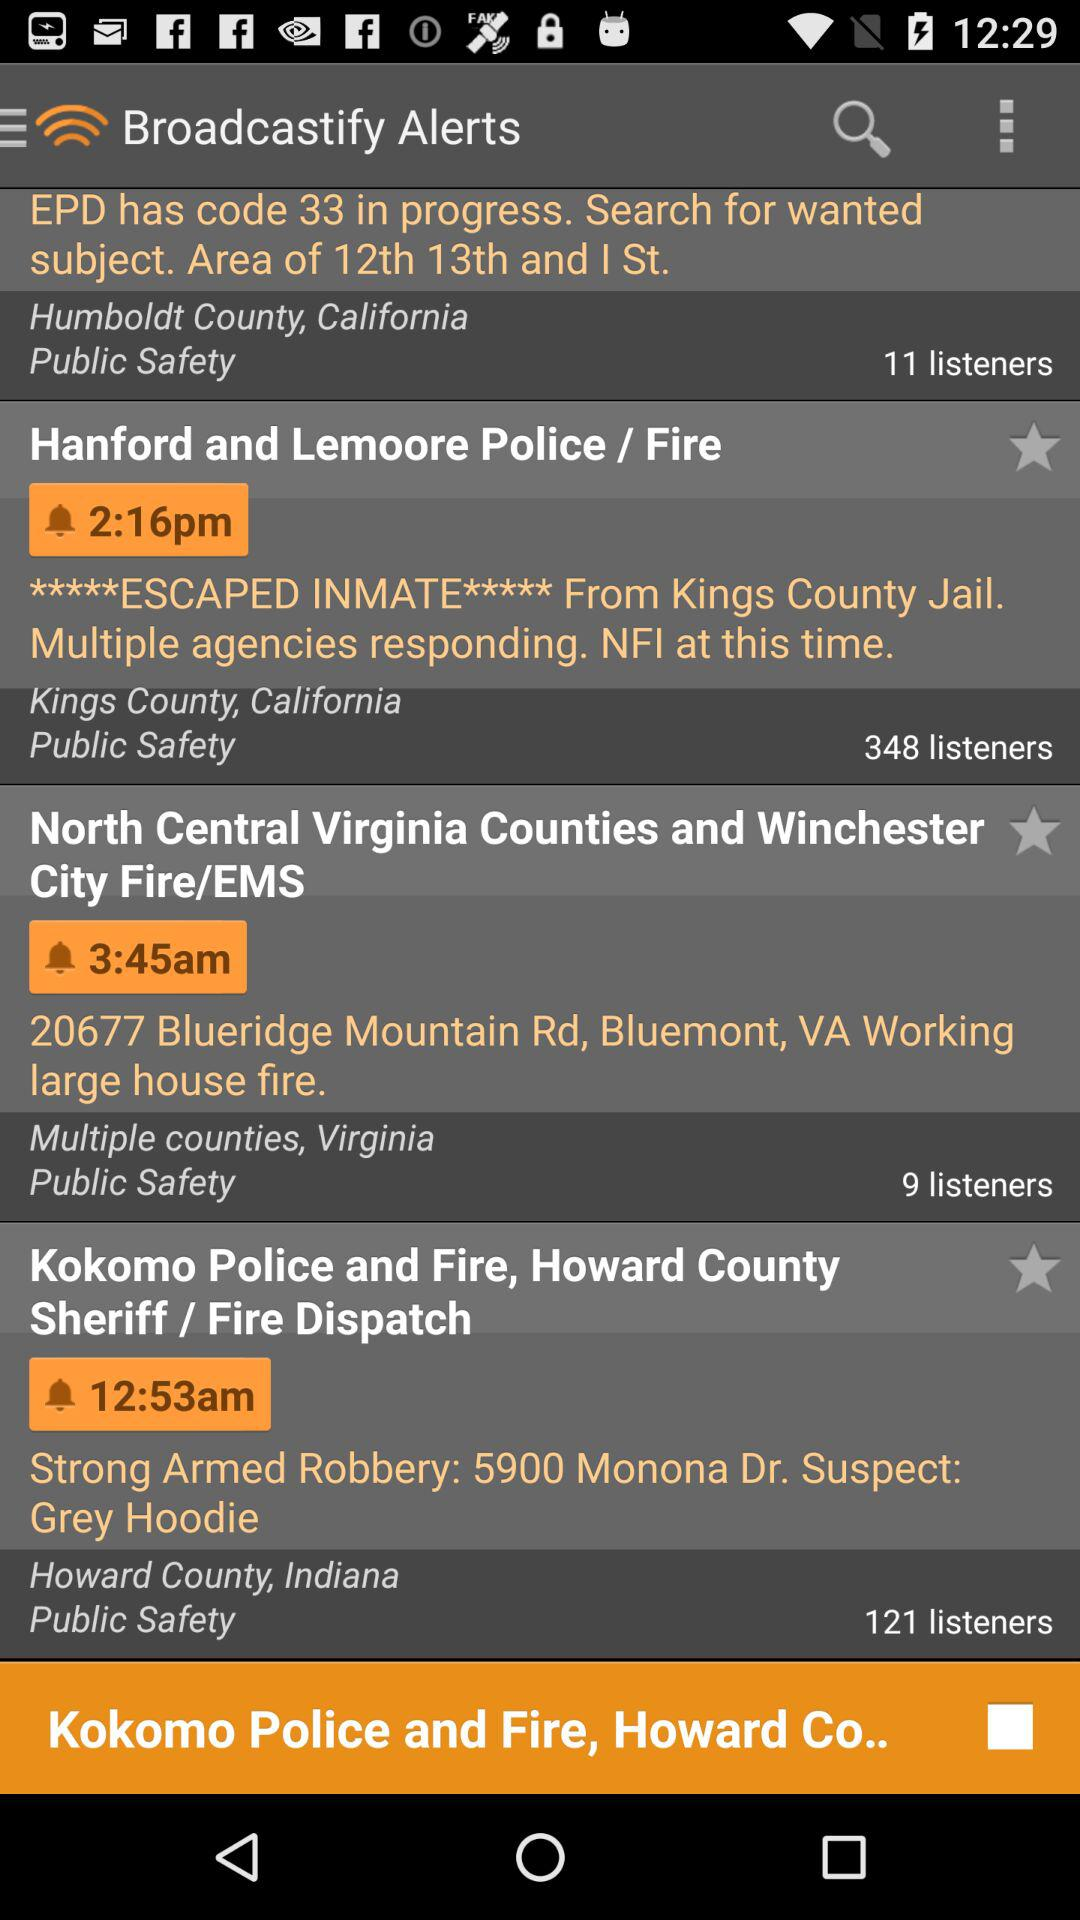What is the time mentioned for multiple counties in Virginia? The mentioned time is 3:45 am. 